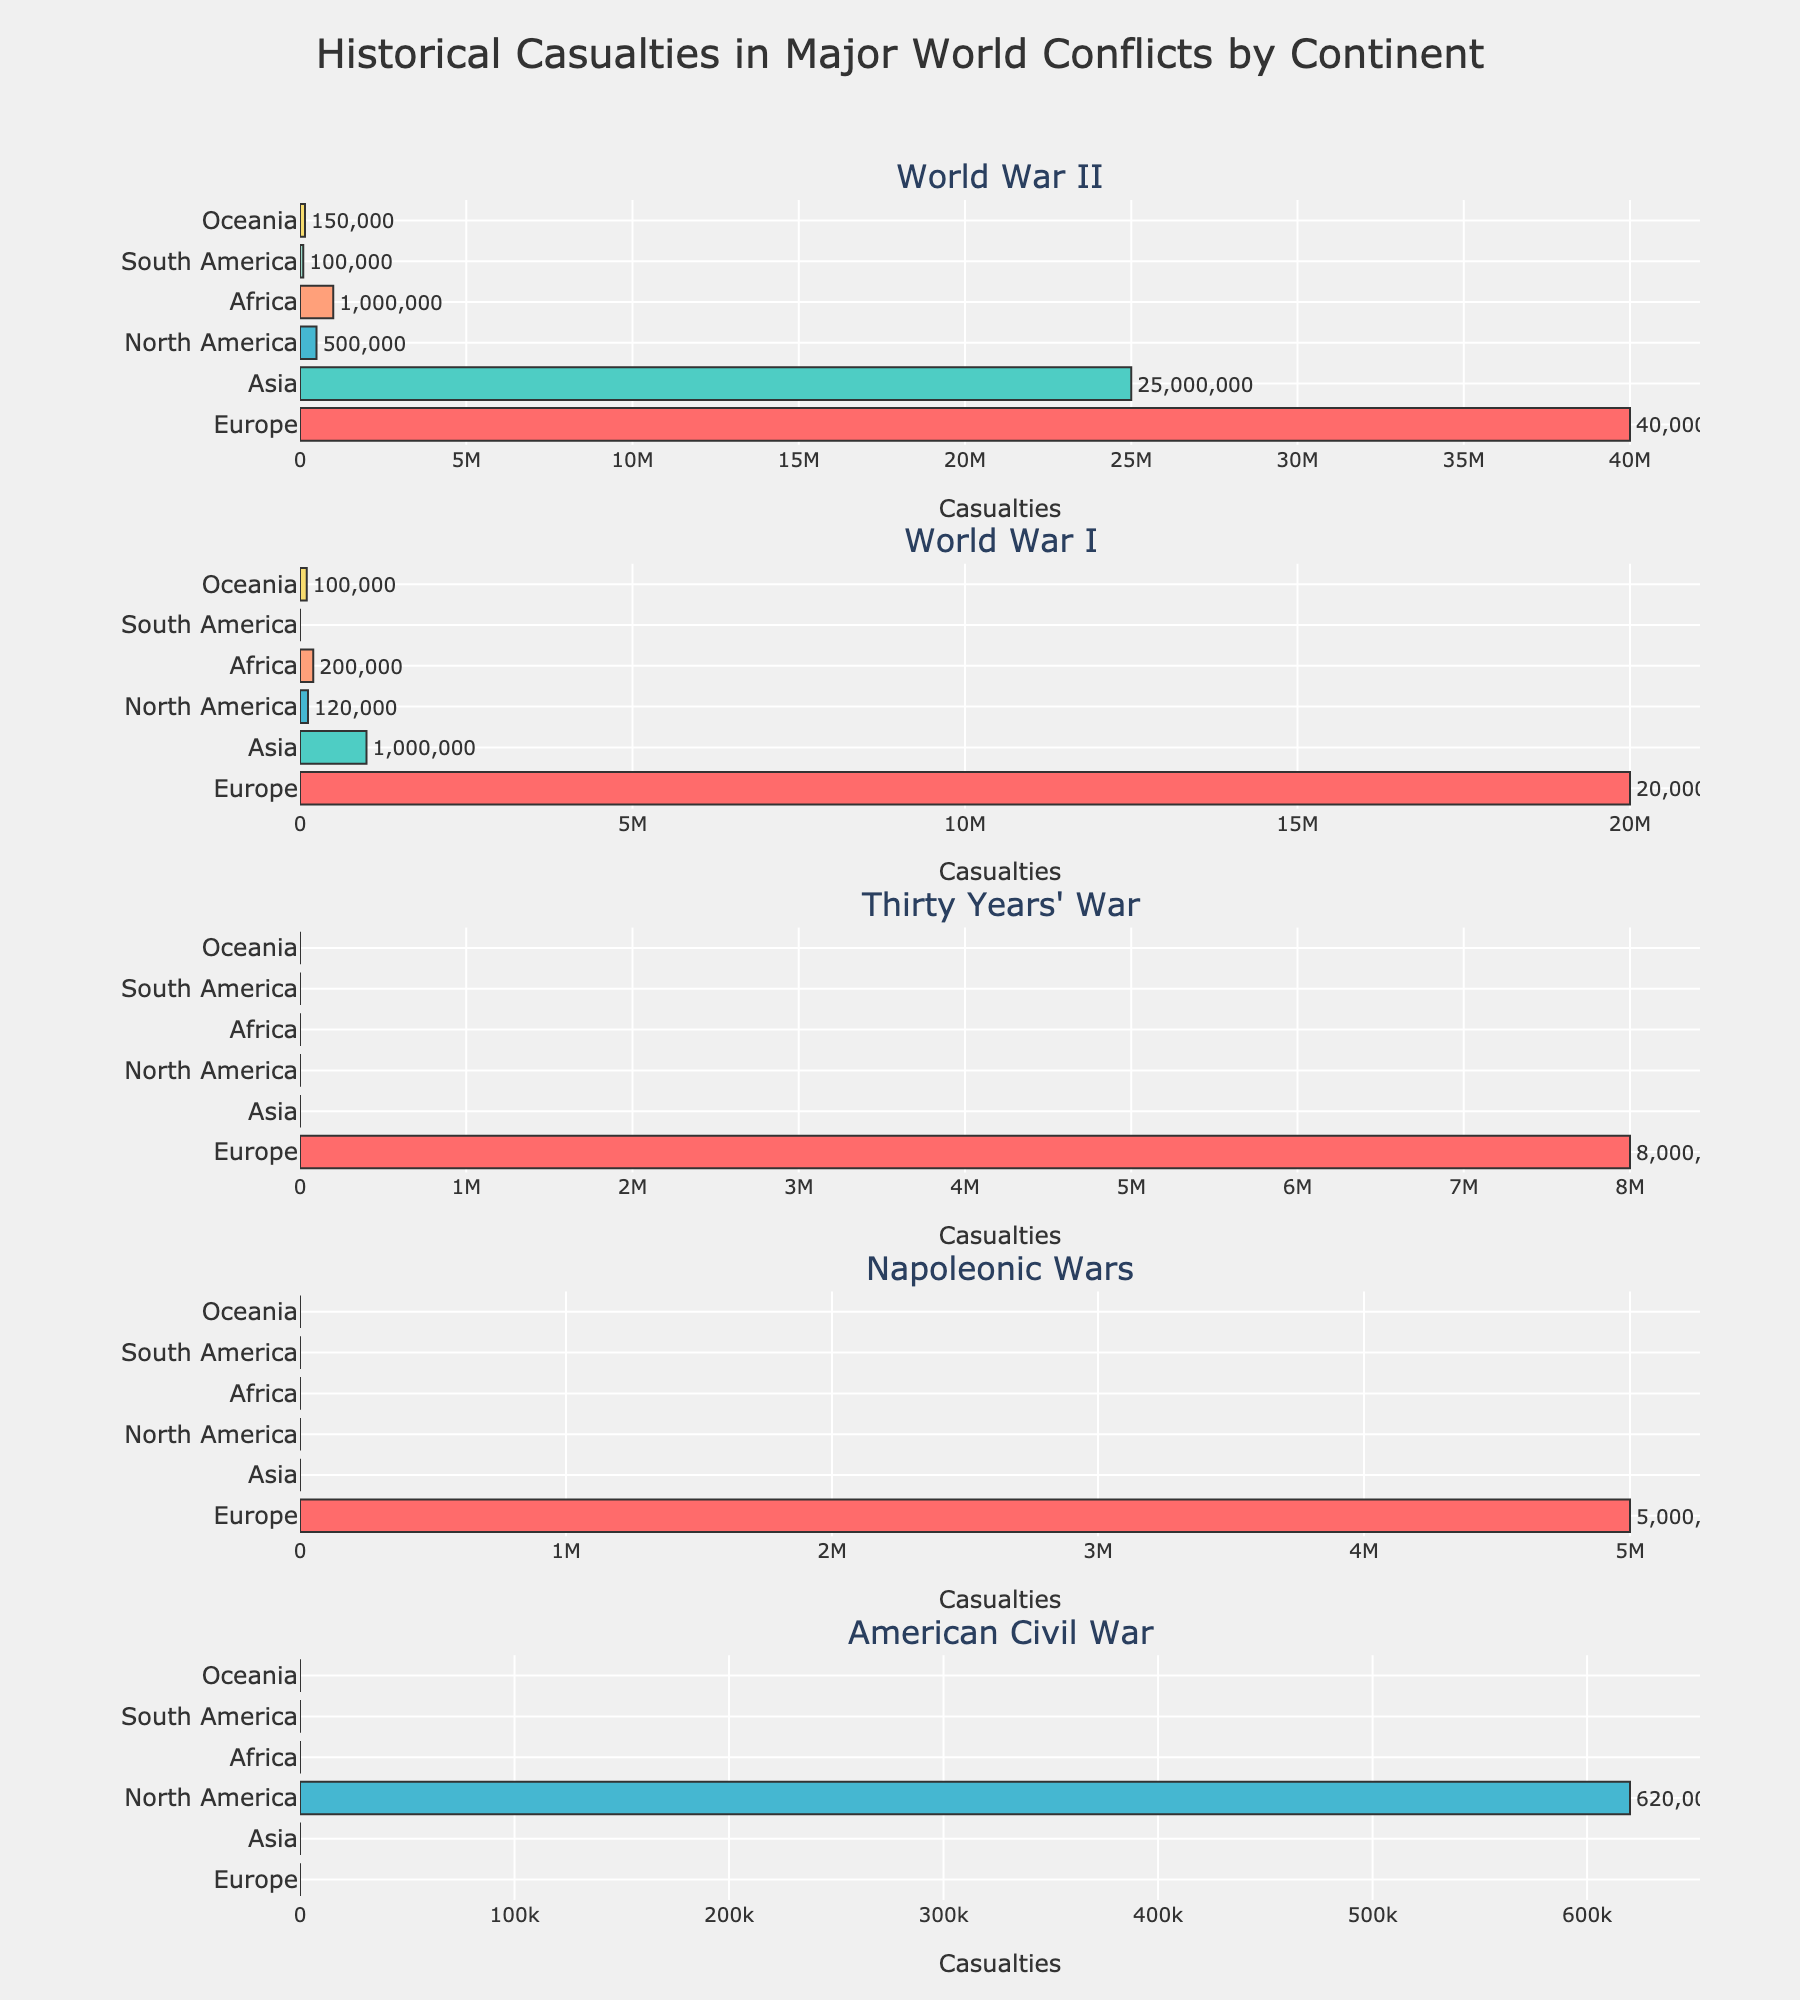Which continent had the highest casualties during World War II? To find the answer, look at the World War II subplot and identify the longest bar, which corresponds to the continent with the highest casualties.
Answer: Europe How many continents have data for casualties in the Napoleonic Wars? Examine the Napoleonic Wars subplot and count the number of bars present.
Answer: One Compare the casualties in World War I and World War II for Asia. Which war had more casualties? Look at the bars in the Asia section for both World War I and World War II subplots and compare their lengths and values.
Answer: World War II Which conflict shows casualties for the most continents? Check each conflict's subplot and count the unique continents with data (i.e., non-zero values) in each subplot. Identify the conflict with the highest count.
Answer: World War II What is the sum of casualties in North America across all listed conflicts? Add the casualties for North America from the bars across all subplots: 500,000 (WWII) + 120,000 (WWI) + 0 (Thirty Years' War) + 0 (Napoleonic Wars) + 620,000 (American Civil War).
Answer: 1,240,000 Which continent has the second-highest casualties in the Thirty Years' War? Since only Europe has casualties listed for the Thirty Years' War, which is 8,000,000, no other continents are present. Hence, there's no second-highest.
Answer: No other continent listed How do the casualties in Oceania during World War II compare to those in the American Civil War in North America? Look at the bars for Oceania in World War II and North America in the American Civil War, and compare their lengths and values: 150,000 (Oceania, WWII) and 620,000 (North America, American Civil War).
Answer: American Civil War in North America had more Which conflict has the least casualties overall, and how many are they? Sum up the casualties for each conflict across all continents and identify the conflict with the smallest total. For Thirty Years' War, it’s 8,000,000 (Europe only). For American Civil War: 620,000 (North America only). So the least is in the Napoleonic Wars.
Answer: Napoleonic Wars with 5,000,000 What are the casualties in Africa during World War I compared to South America during World War II? Look at the bars for Africa in World War I and South America in World War II, and compare their values: 200,000 (Africa, WWI) and 100,000 (South America, WWII).
Answer: Africa had more in WWI What percentage of World War II casualties were in Asia, relative to the total casualties in Europe and Asia in the same conflict? Sum the casualties in Europe and Asia during World War II: 40,000,000 (Europe) + 25,000,000 (Asia) = 65,000,000. Calculate the percentage for Asia: (25,000,000 / 65,000,000) * 100.
Answer: 38.46% 